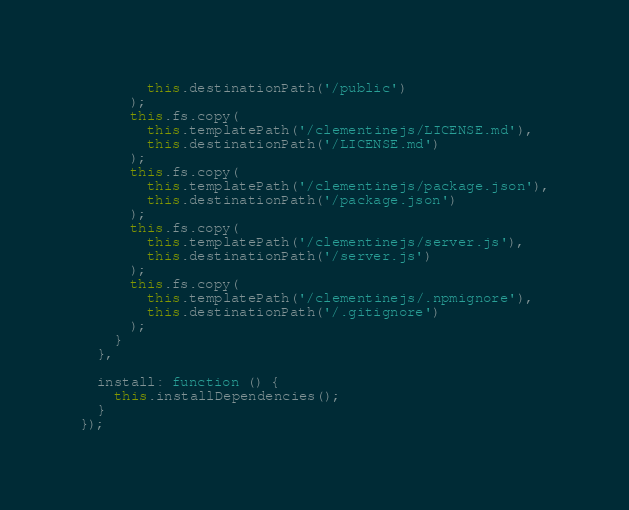Convert code to text. <code><loc_0><loc_0><loc_500><loc_500><_JavaScript_>        this.destinationPath('/public')
      );
      this.fs.copy(
        this.templatePath('/clementinejs/LICENSE.md'),
        this.destinationPath('/LICENSE.md')
      );
      this.fs.copy(
        this.templatePath('/clementinejs/package.json'),
        this.destinationPath('/package.json')
      );
      this.fs.copy(
        this.templatePath('/clementinejs/server.js'),
        this.destinationPath('/server.js')
      );
      this.fs.copy(
        this.templatePath('/clementinejs/.npmignore'),
        this.destinationPath('/.gitignore')
      );
    }
  },

  install: function () {
    this.installDependencies();
  }
});
</code> 